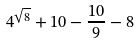Convert formula to latex. <formula><loc_0><loc_0><loc_500><loc_500>4 ^ { \sqrt { 8 } } + 1 0 - \frac { 1 0 } { 9 } - 8</formula> 